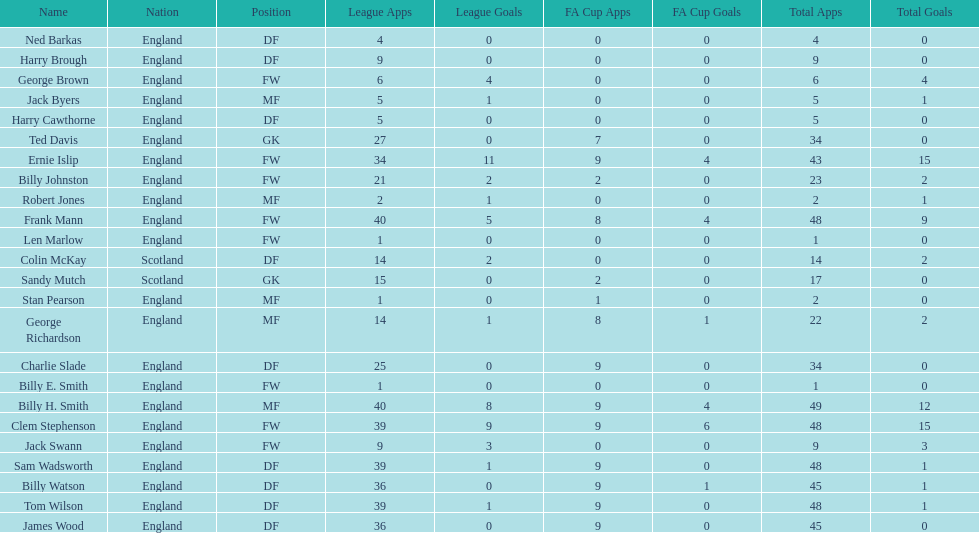What is the average number of scotland's total apps? 15.5. 